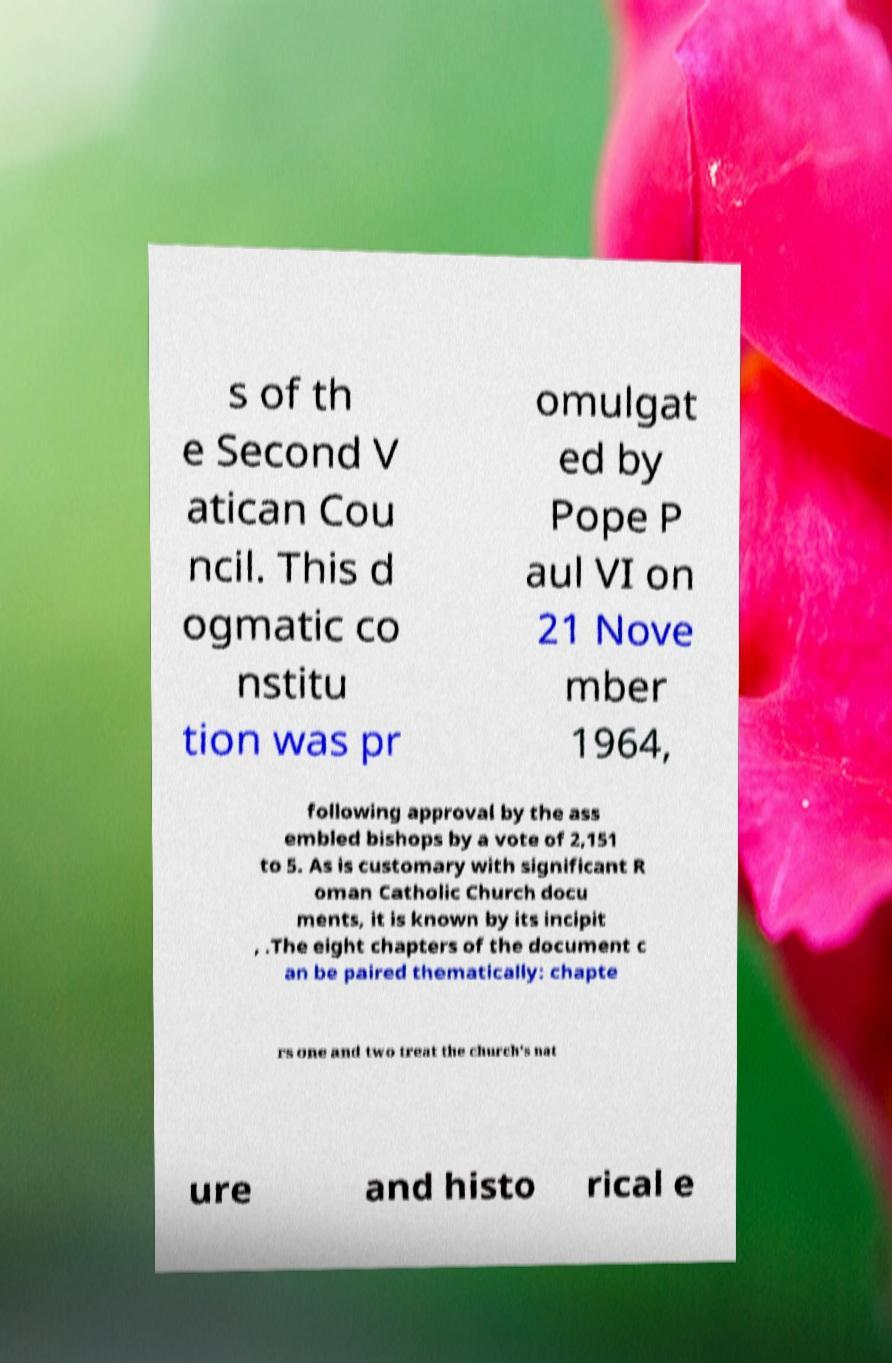I need the written content from this picture converted into text. Can you do that? s of th e Second V atican Cou ncil. This d ogmatic co nstitu tion was pr omulgat ed by Pope P aul VI on 21 Nove mber 1964, following approval by the ass embled bishops by a vote of 2,151 to 5. As is customary with significant R oman Catholic Church docu ments, it is known by its incipit , .The eight chapters of the document c an be paired thematically: chapte rs one and two treat the church's nat ure and histo rical e 